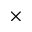<formula> <loc_0><loc_0><loc_500><loc_500>\times</formula> 